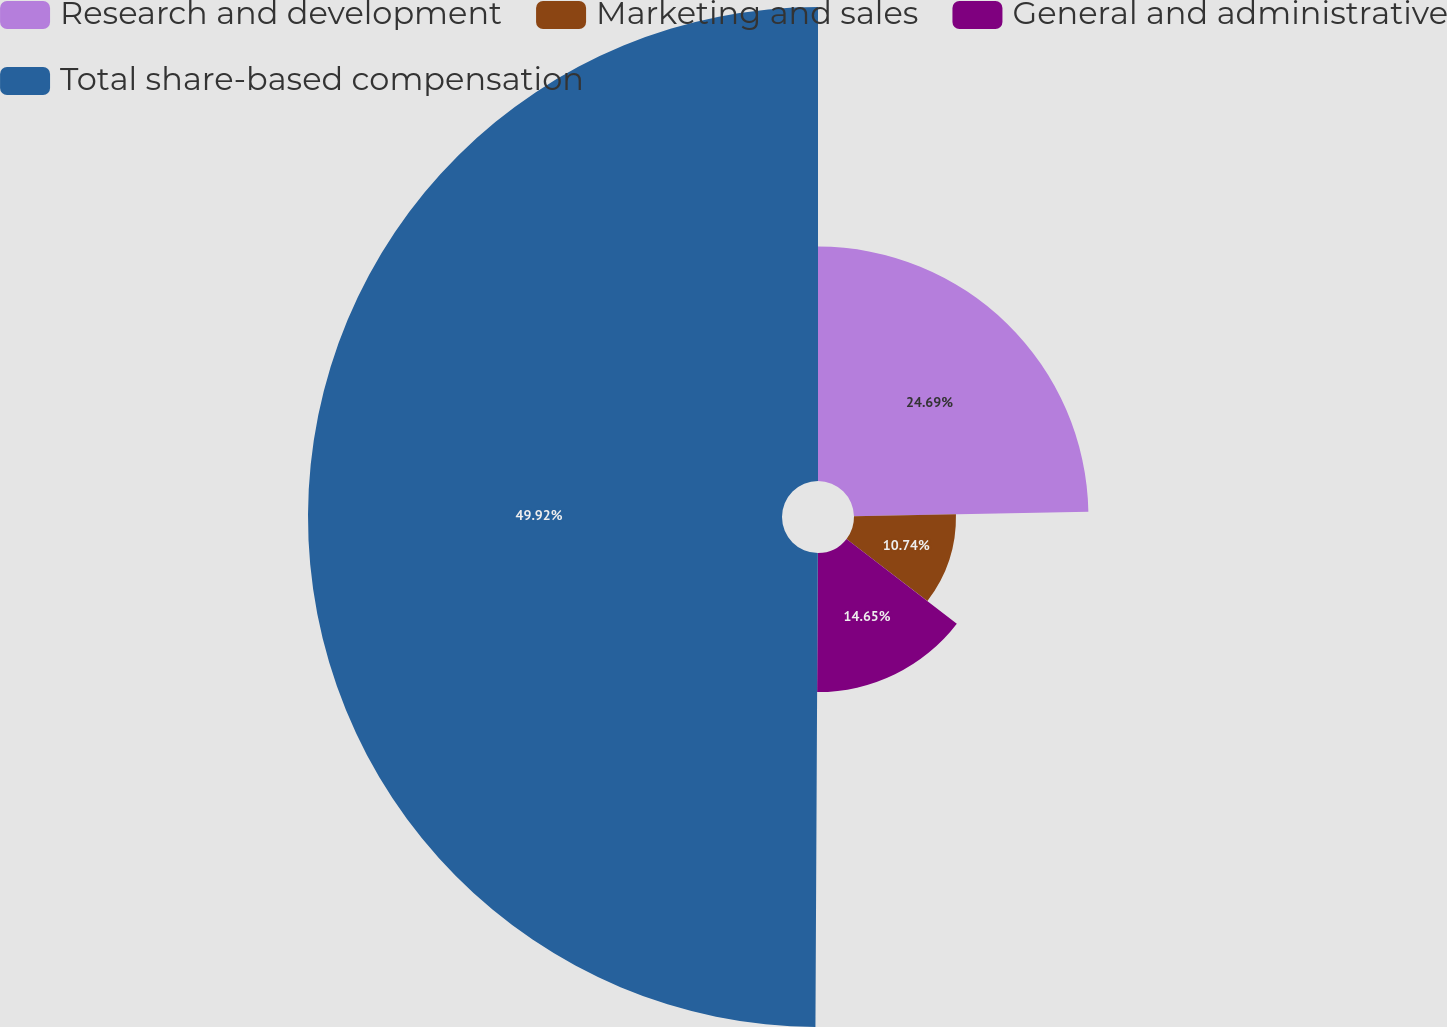Convert chart. <chart><loc_0><loc_0><loc_500><loc_500><pie_chart><fcel>Research and development<fcel>Marketing and sales<fcel>General and administrative<fcel>Total share-based compensation<nl><fcel>24.69%<fcel>10.74%<fcel>14.65%<fcel>49.92%<nl></chart> 